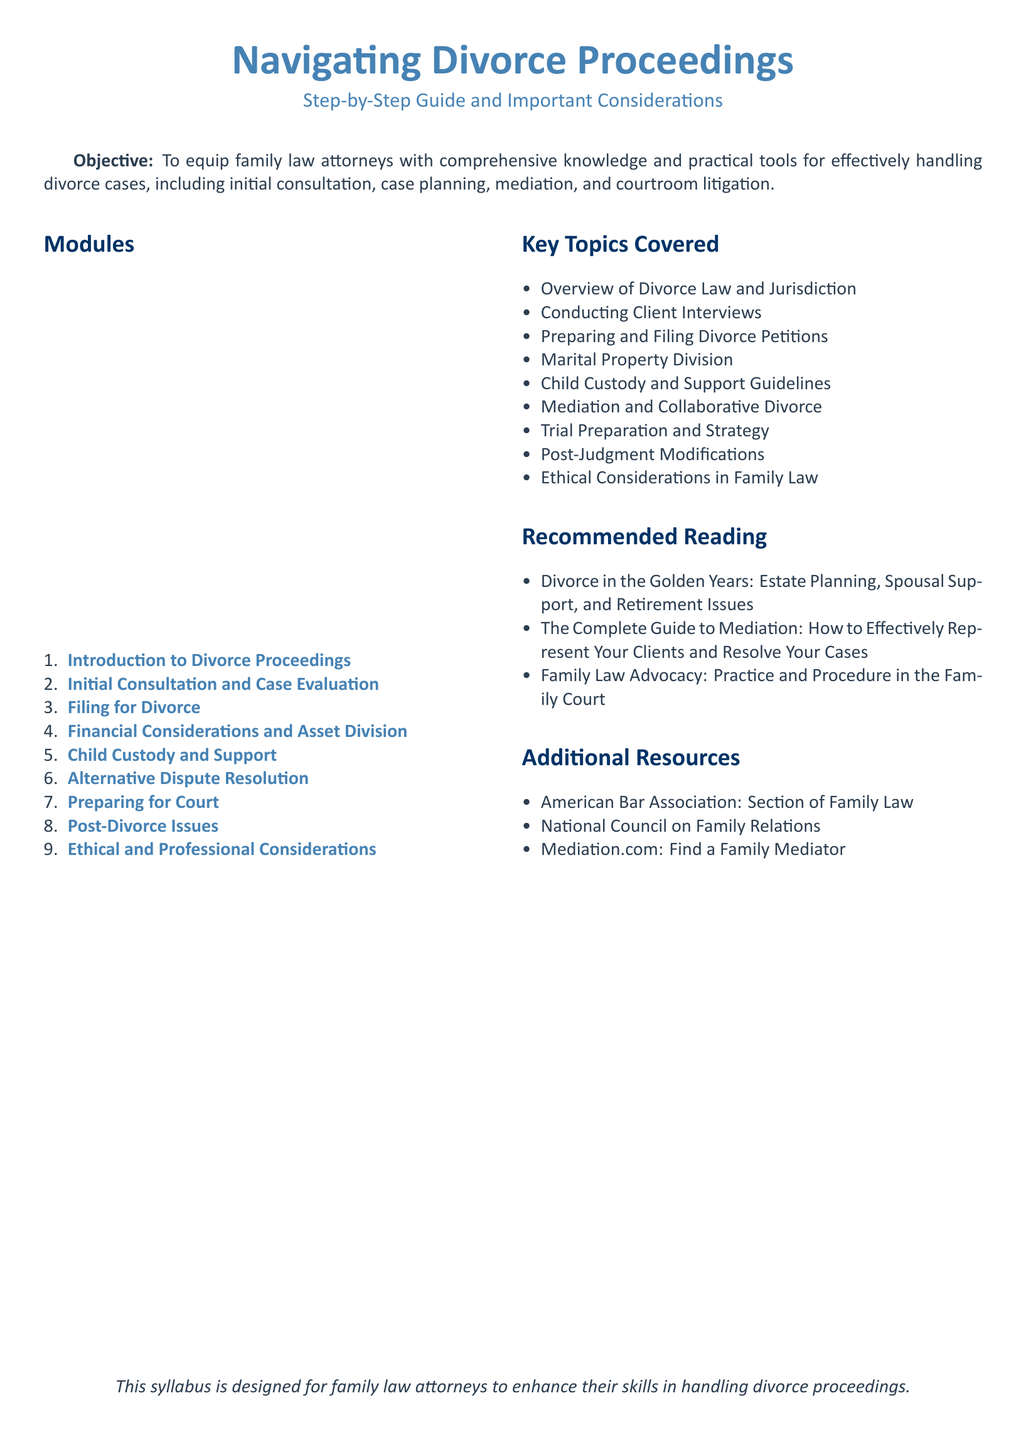What is the title of the syllabus? The title is presented prominently at the top of the document, making it easy to identify.
Answer: Navigating Divorce Proceedings How many modules are included in the syllabus? The total number of modules is listed in the modules section of the syllabus.
Answer: Nine What is the first module in the syllabus? The first module is specified in the list of modules at the beginning of the document.
Answer: Introduction to Divorce Proceedings Which key topic covers alternative dispute methods? The key topics covered include various aspects of divorce law, including methods for resolving disputes outside of court.
Answer: Alternative Dispute Resolution Name one recommended reading listed in the syllabus. The recommended readings are detailed in a separate section, providing resources for further knowledge.
Answer: Divorce in the Golden Years: Estate Planning, Spousal Support, and Retirement Issues What kind of issues does the last module address? The modules detail various considerations relevant to divorce, with the last module focusing on a specific type of post-divorce matters.
Answer: Ethical and Professional Considerations What organization is mentioned as a resource in the additional resources section? The organizations provided offer further support and resources for family law attorneys beyond the syllabus.
Answer: American Bar Association: Section of Family Law 